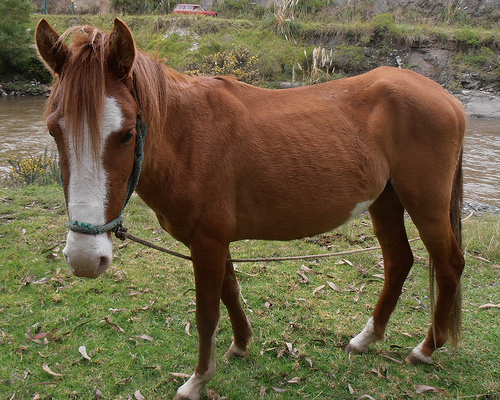<image>
Is there a animal under the grass? No. The animal is not positioned under the grass. The vertical relationship between these objects is different. Is the animal behind the grass? No. The animal is not behind the grass. From this viewpoint, the animal appears to be positioned elsewhere in the scene. 